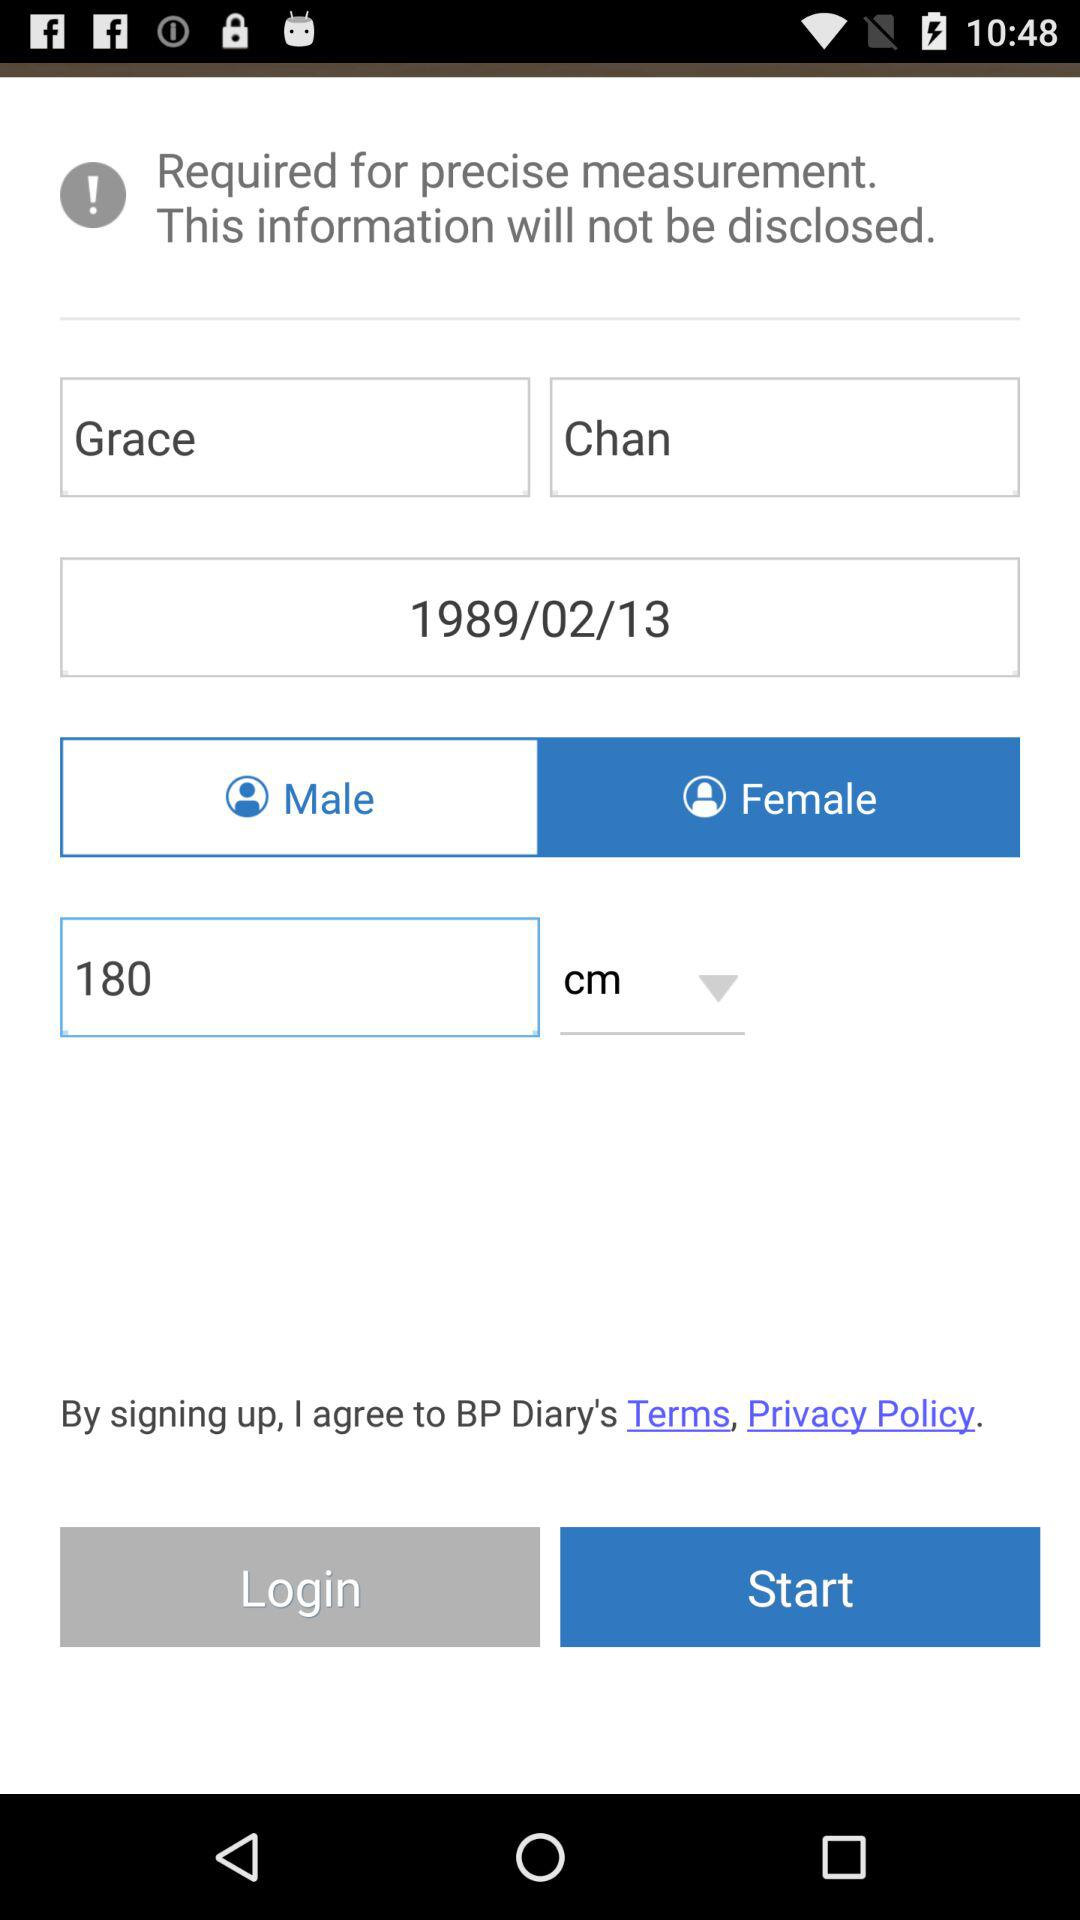What is the mentioned date? The mentioned date is February 13, 1989. 